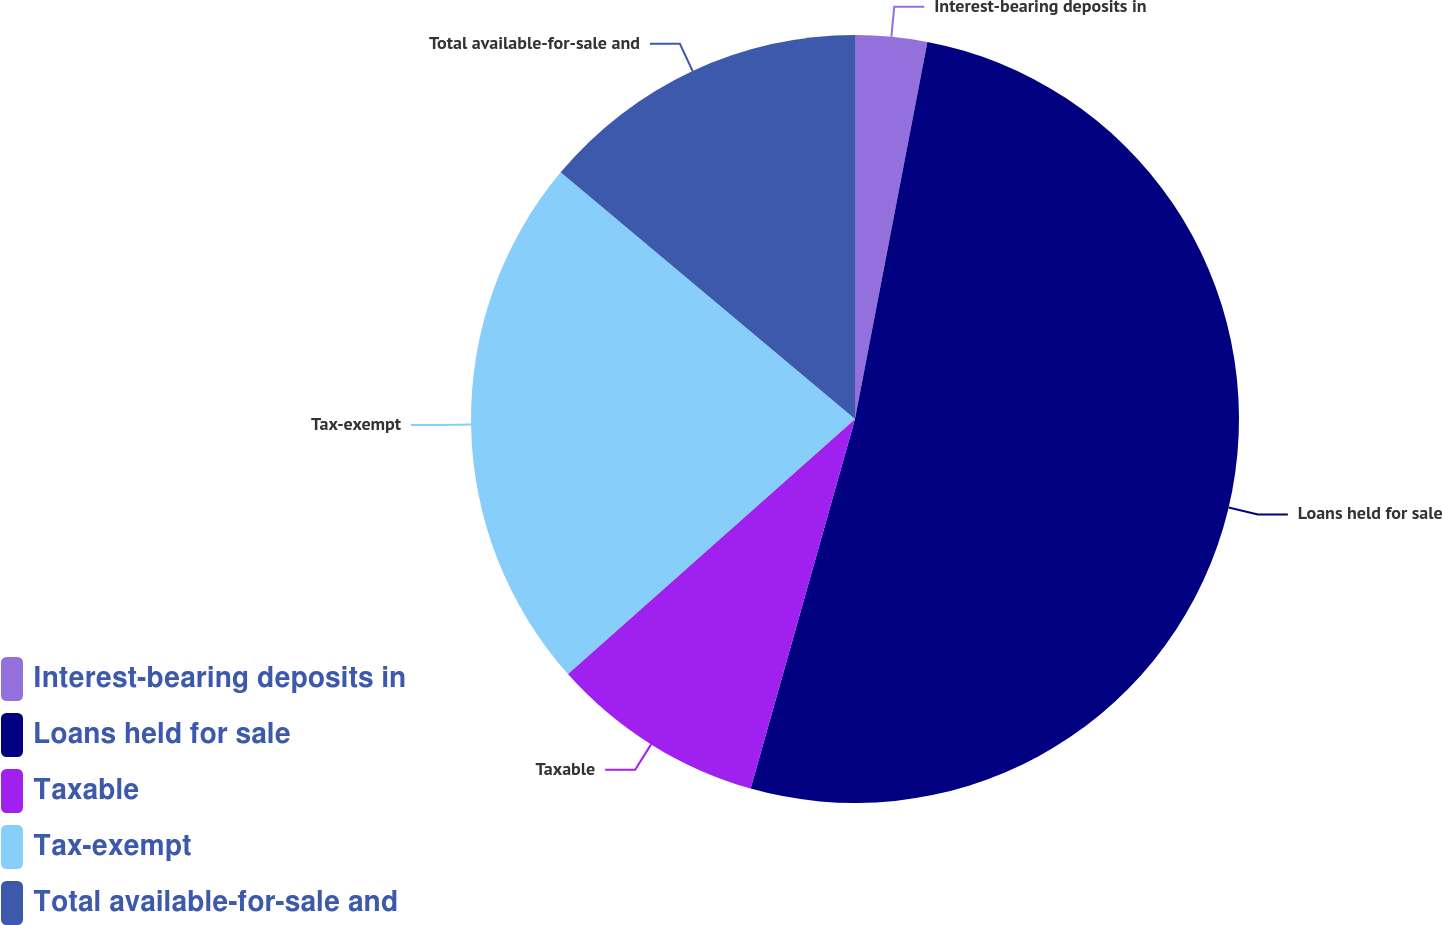<chart> <loc_0><loc_0><loc_500><loc_500><pie_chart><fcel>Interest-bearing deposits in<fcel>Loans held for sale<fcel>Taxable<fcel>Tax-exempt<fcel>Total available-for-sale and<nl><fcel>3.02%<fcel>51.36%<fcel>9.06%<fcel>22.66%<fcel>13.9%<nl></chart> 